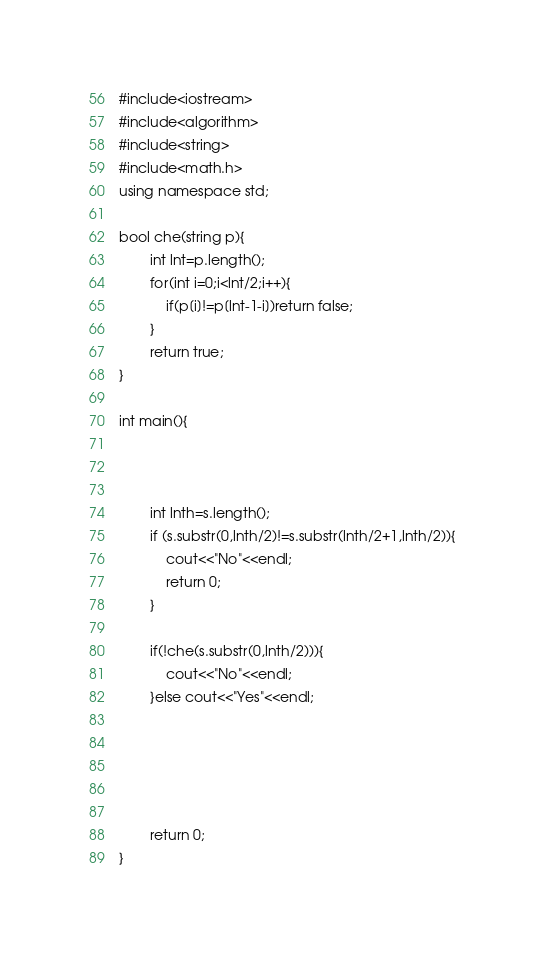<code> <loc_0><loc_0><loc_500><loc_500><_C++_>#include<iostream>
#include<algorithm>
#include<string>
#include<math.h>
using namespace std;

bool che(string p){
		int lnt=p.length();
		for(int i=0;i<lnt/2;i++){
			if(p[i]!=p[lnt-1-i])return false;
		}
		return true;
}

int main(){
		
		
		
		int lnth=s.length();
		if (s.substr(0,lnth/2)!=s.substr(lnth/2+1,lnth/2)){
			cout<<"No"<<endl;
			return 0;
		}
		
		if(!che(s.substr(0,lnth/2))){
			cout<<"No"<<endl;
		}else cout<<"Yes"<<endl;
			
		
		

	
		return 0;
}

</code> 